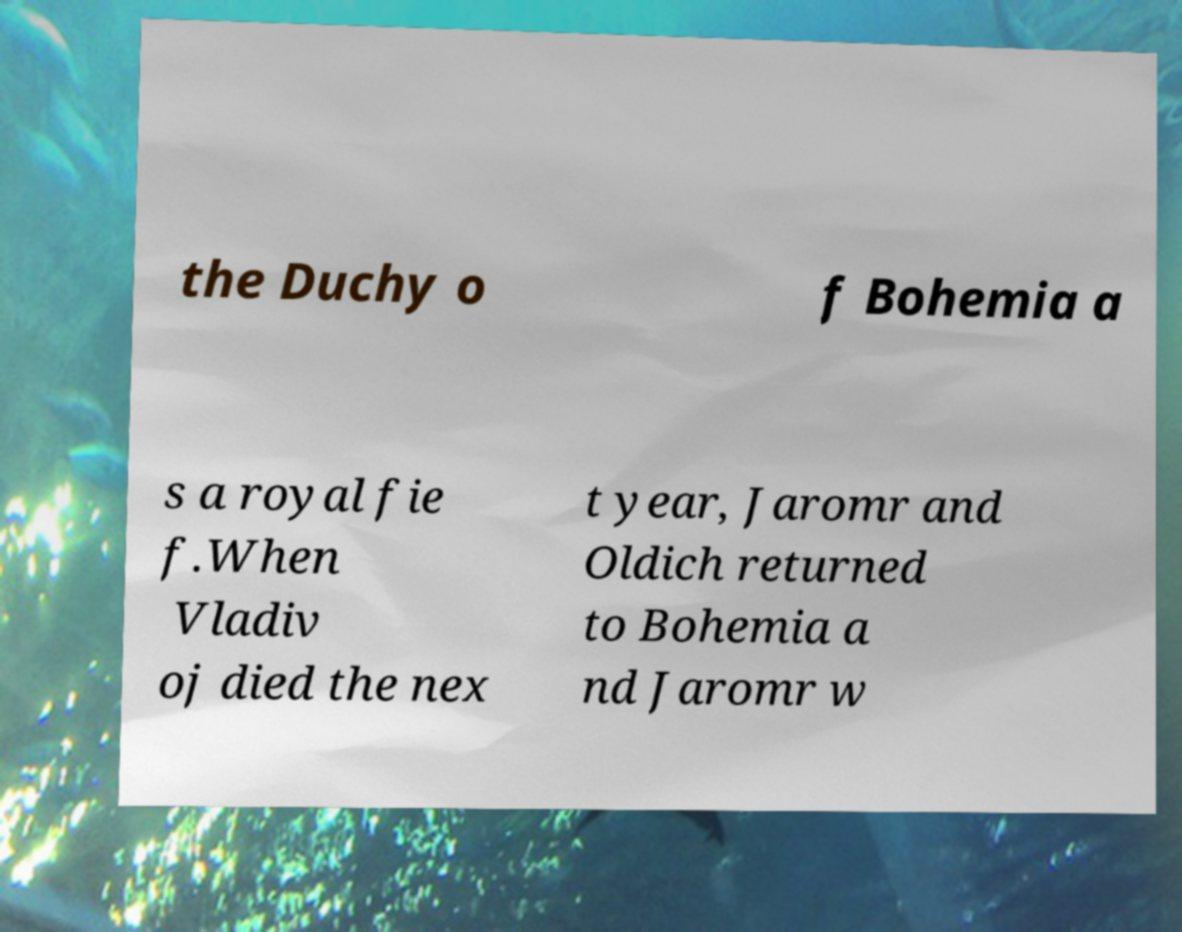Could you assist in decoding the text presented in this image and type it out clearly? the Duchy o f Bohemia a s a royal fie f.When Vladiv oj died the nex t year, Jaromr and Oldich returned to Bohemia a nd Jaromr w 